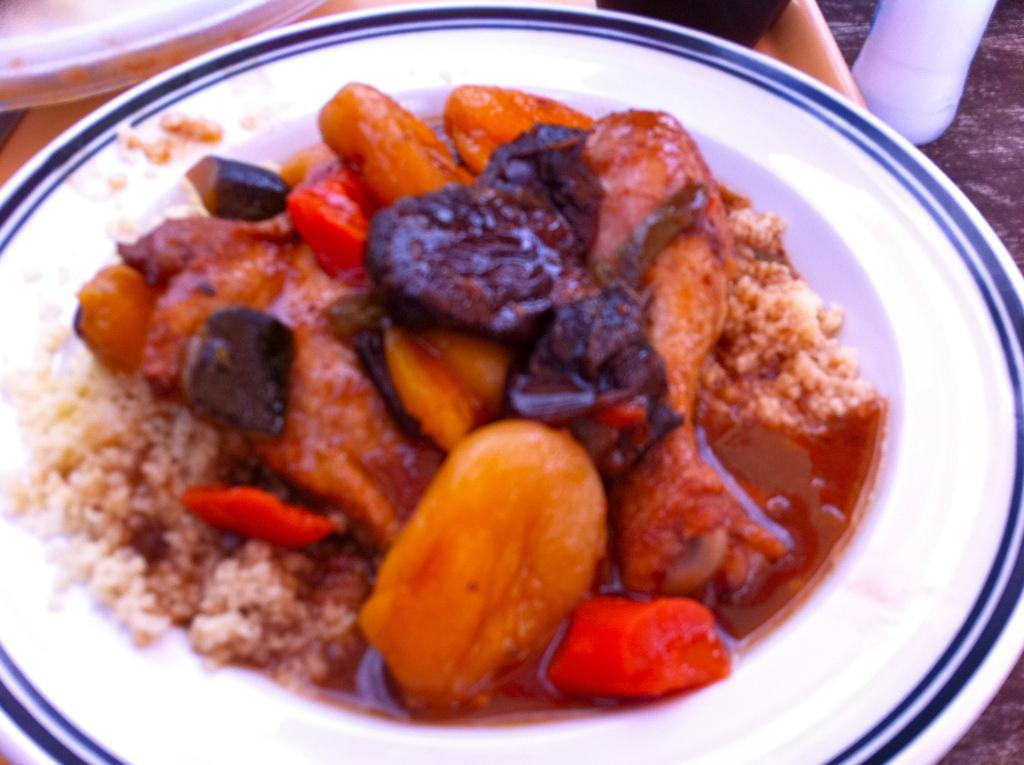What is on the plate that is visible in the image? There is a plate with food in the image. What else can be seen on the wooden surface in the image? There are objects on a wooden surface in the image. What type of quiver is present in the image? There is no quiver present in the image. What government policy is being discussed in the image? There is no discussion of government policy in the image. 